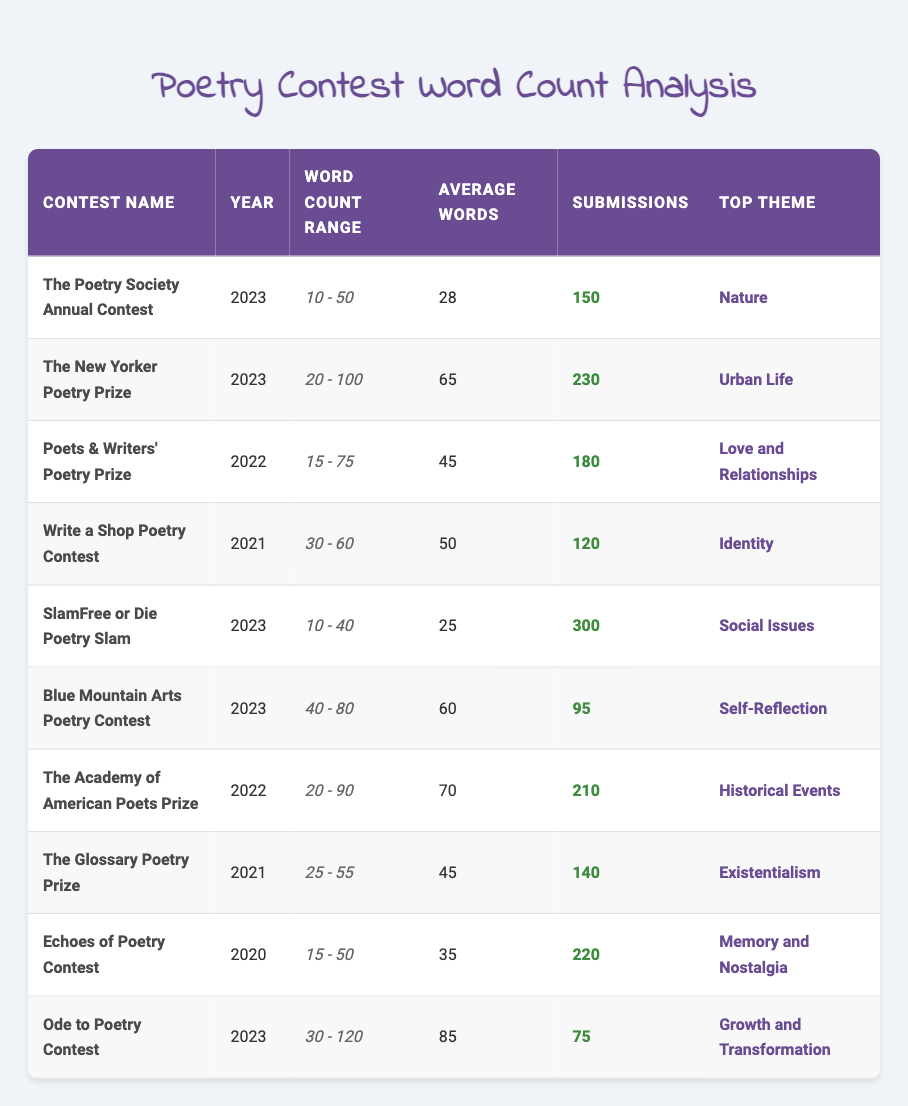What is the submission count for The New Yorker Poetry Prize? The submission count is listed directly in the table under the column titled "Submissions" for The New Yorker Poetry Prize in the year 2023, which shows 230.
Answer: 230 What is the maximum word count for the Ode to Poetry Contest? The maximum word count can be found in the "Word Count Range" column for the Ode to Poetry Contest in 2023, which shows a maximum of 120 words.
Answer: 120 Which contest has the highest average word count? To find the contest with the highest average word count, we compare the average values across all contests. The Ode to Poetry Contest has an average of 85, which is the highest.
Answer: Ode to Poetry Contest Is the top theme for SlamFree or Die Poetry Slam Social Issues? Checking the "Top Theme" column for SlamFree or Die Poetry Slam in 2023 shows that the theme listed is "Social Issues."
Answer: Yes What is the total number of submissions for contests held in 2023? To find the total submissions for 2023 contests, we add the submission counts for each contest that occurred in that year: 150 (The Poetry Society Annual Contest) + 230 (The New Yorker Poetry Prize) + 300 (SlamFree or Die Poetry Slam) + 95 (Blue Mountain Arts Poetry Contest) + 75 (Ode to Poetry Contest) = 850.
Answer: 850 Which contest had the lowest average word count in 2023? Looking at the average word counts for 2023 contests, the one with the lowest average is the SlamFree or Die Poetry Slam, which has an average of 25 words.
Answer: SlamFree or Die Poetry Slam How many contests had 'Love and Relationships' as their top theme? By examining the "Top Theme" column, we see that only the Poets & Writers' Poetry Prize has 'Love and Relationships' listed as its theme.
Answer: 1 What is the average range of word counts for contests in 2022? To find the average range of word counts, we take the contests from 2022: Poets & Writers' Poetry Prize (15-75) and The Academy of American Poets Prize (20-90). The ranges average to (75 + 90) / 2 = 82.5 for maximum and (15 + 20) / 2 = 17.5 for minimum. Therefore, the average range for contests in 2022 is roughly 17.5-82.5.
Answer: Approximately 17.5 - 82.5 